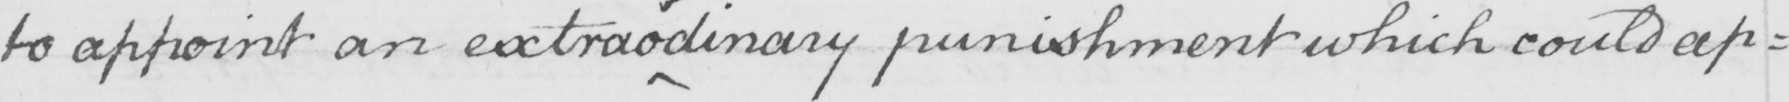Please provide the text content of this handwritten line. to appoint an extrao dinary punishment which could ap= 